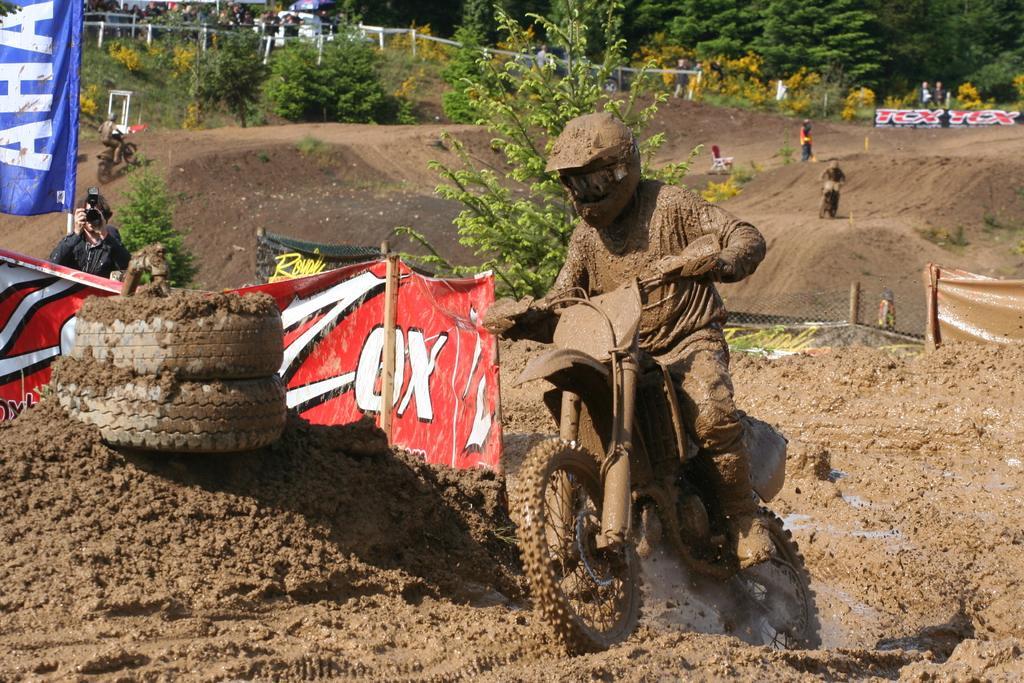Please provide a concise description of this image. In this image I can see a person riding a motorcycle in the mud, wearing a helmet. There are banners and a person is holding a camera on the left. There are other people, fence and trees at the back. 